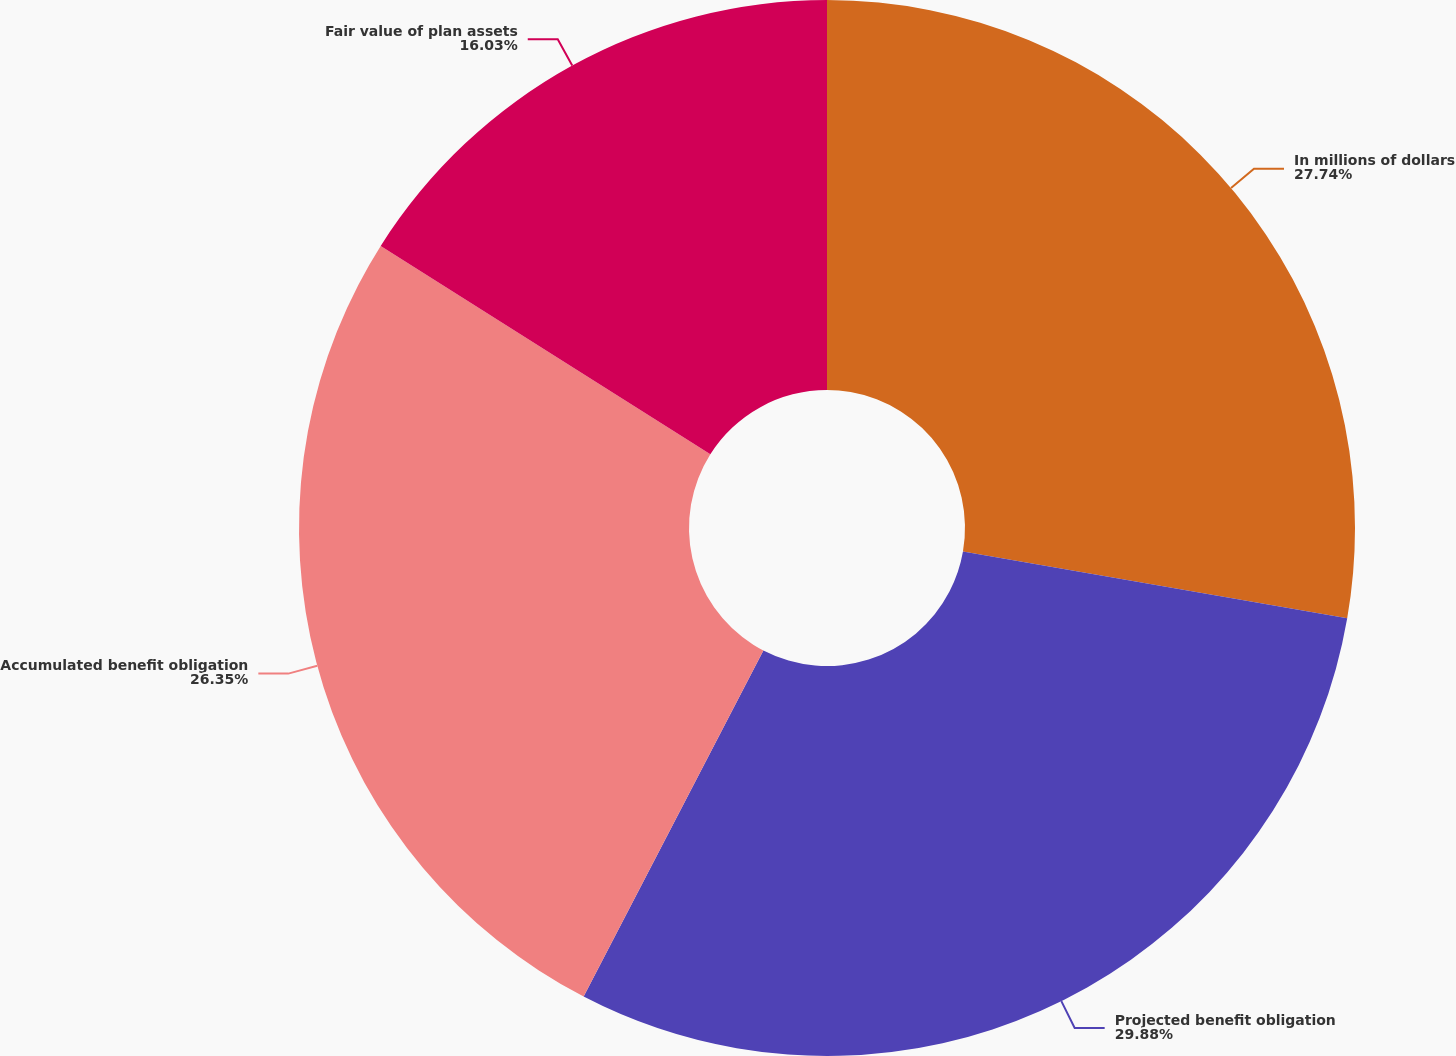<chart> <loc_0><loc_0><loc_500><loc_500><pie_chart><fcel>In millions of dollars<fcel>Projected benefit obligation<fcel>Accumulated benefit obligation<fcel>Fair value of plan assets<nl><fcel>27.74%<fcel>29.89%<fcel>26.35%<fcel>16.03%<nl></chart> 